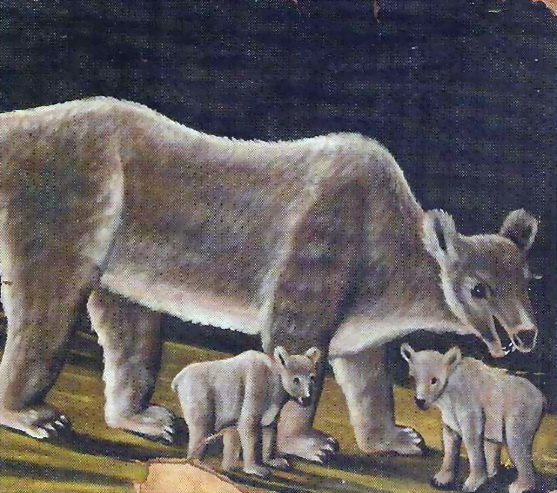Imagine the forest where these bears live is enchanted. What magical elements might exist there? In the enchanted forest where the bears reside, the air shimmers with a mystical glow. Trees have faces and whisper ancient secrets to each other, their branches swaying gently as if communicating with the wind. The river that flows through the forest sparkles with a silver hue, and its waters are said to have healing properties. Flowers bloom in vibrant colors and emit a soft, musical hum, creating a symphony that only the forest's inhabitants can hear. At night, fireflies gather in clusters to form glowing constellations, lighting up the forest paths. The bears, too, possess their own magic; the mother bear can call upon the forest spirits for protection, and the cubs have the ability to make plants grow by simply touching them. This enchanted haven is a sanctuary, where harmony between nature and magic thrives. 